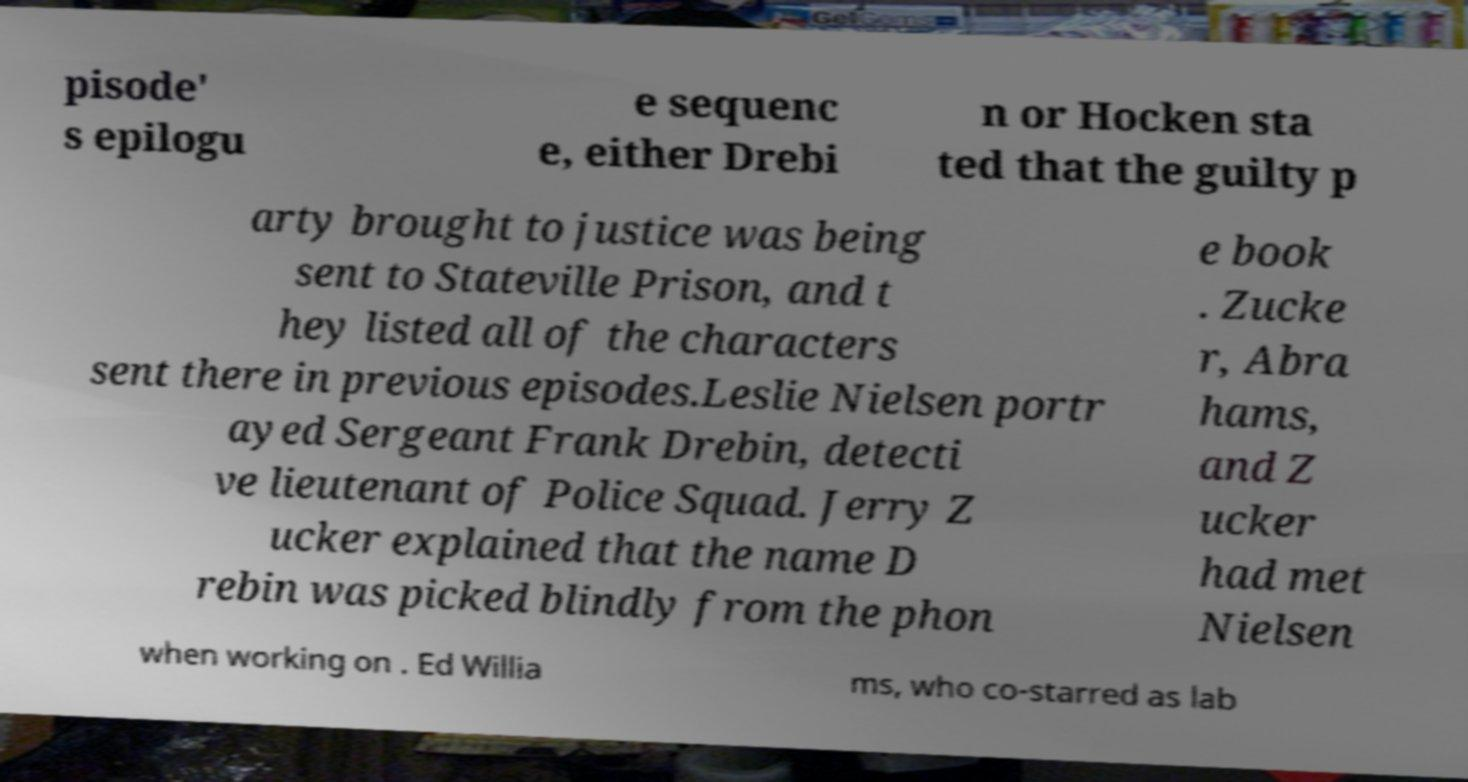I need the written content from this picture converted into text. Can you do that? pisode' s epilogu e sequenc e, either Drebi n or Hocken sta ted that the guilty p arty brought to justice was being sent to Stateville Prison, and t hey listed all of the characters sent there in previous episodes.Leslie Nielsen portr ayed Sergeant Frank Drebin, detecti ve lieutenant of Police Squad. Jerry Z ucker explained that the name D rebin was picked blindly from the phon e book . Zucke r, Abra hams, and Z ucker had met Nielsen when working on . Ed Willia ms, who co-starred as lab 